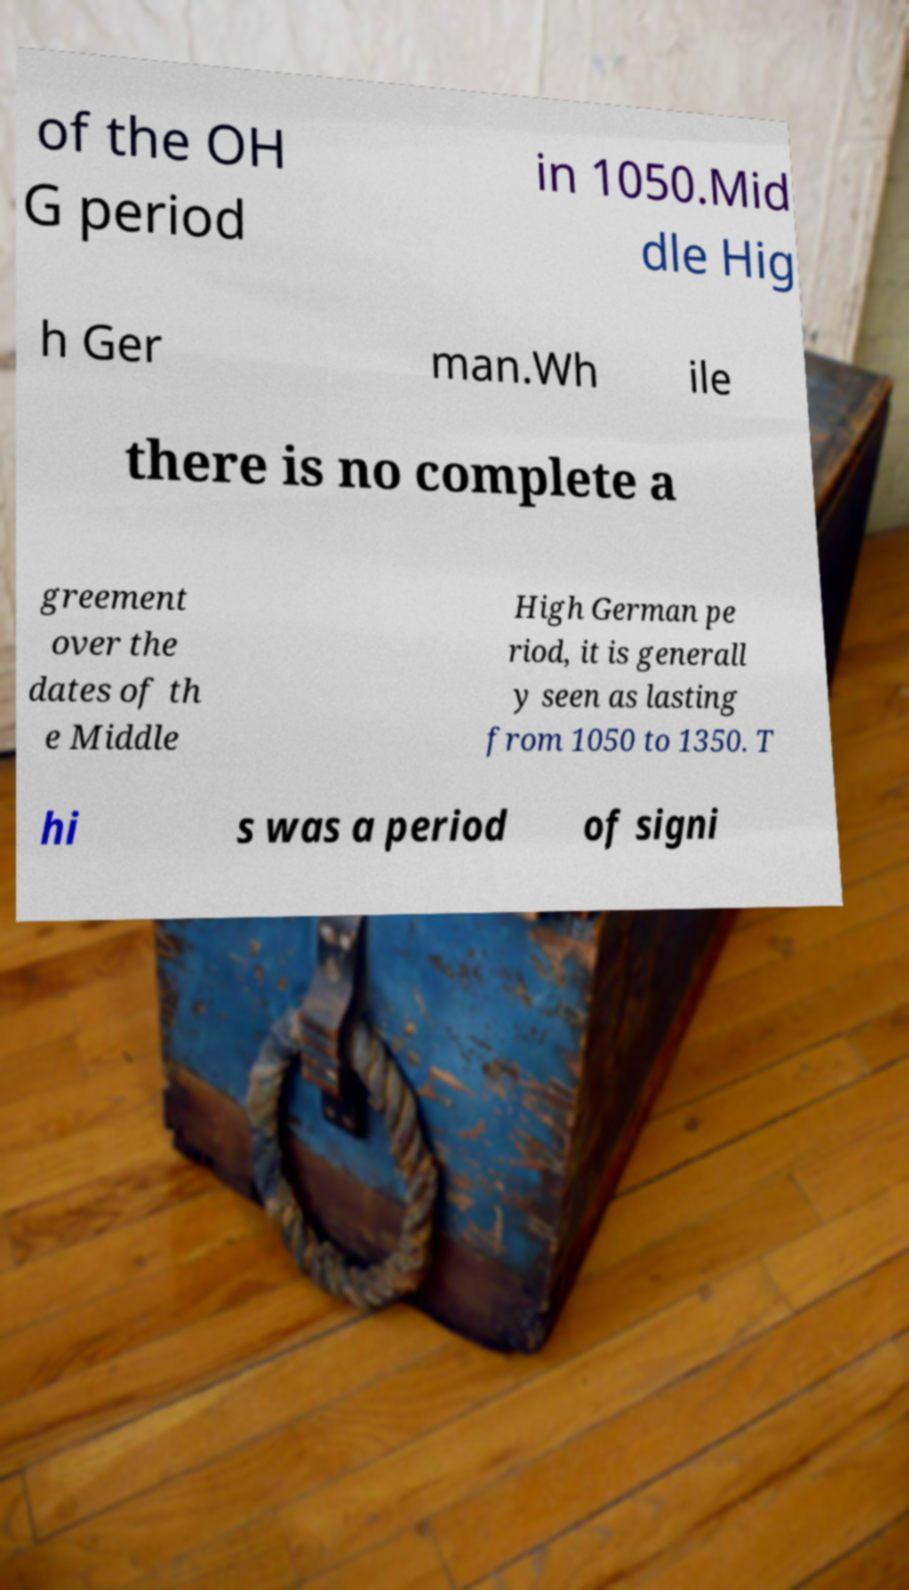Can you read and provide the text displayed in the image?This photo seems to have some interesting text. Can you extract and type it out for me? of the OH G period in 1050.Mid dle Hig h Ger man.Wh ile there is no complete a greement over the dates of th e Middle High German pe riod, it is generall y seen as lasting from 1050 to 1350. T hi s was a period of signi 